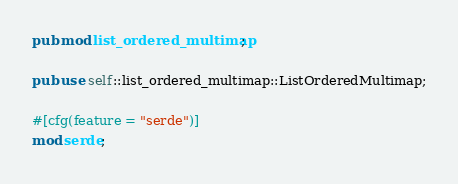<code> <loc_0><loc_0><loc_500><loc_500><_Rust_>pub mod list_ordered_multimap;

pub use self::list_ordered_multimap::ListOrderedMultimap;

#[cfg(feature = "serde")]
mod serde;
</code> 